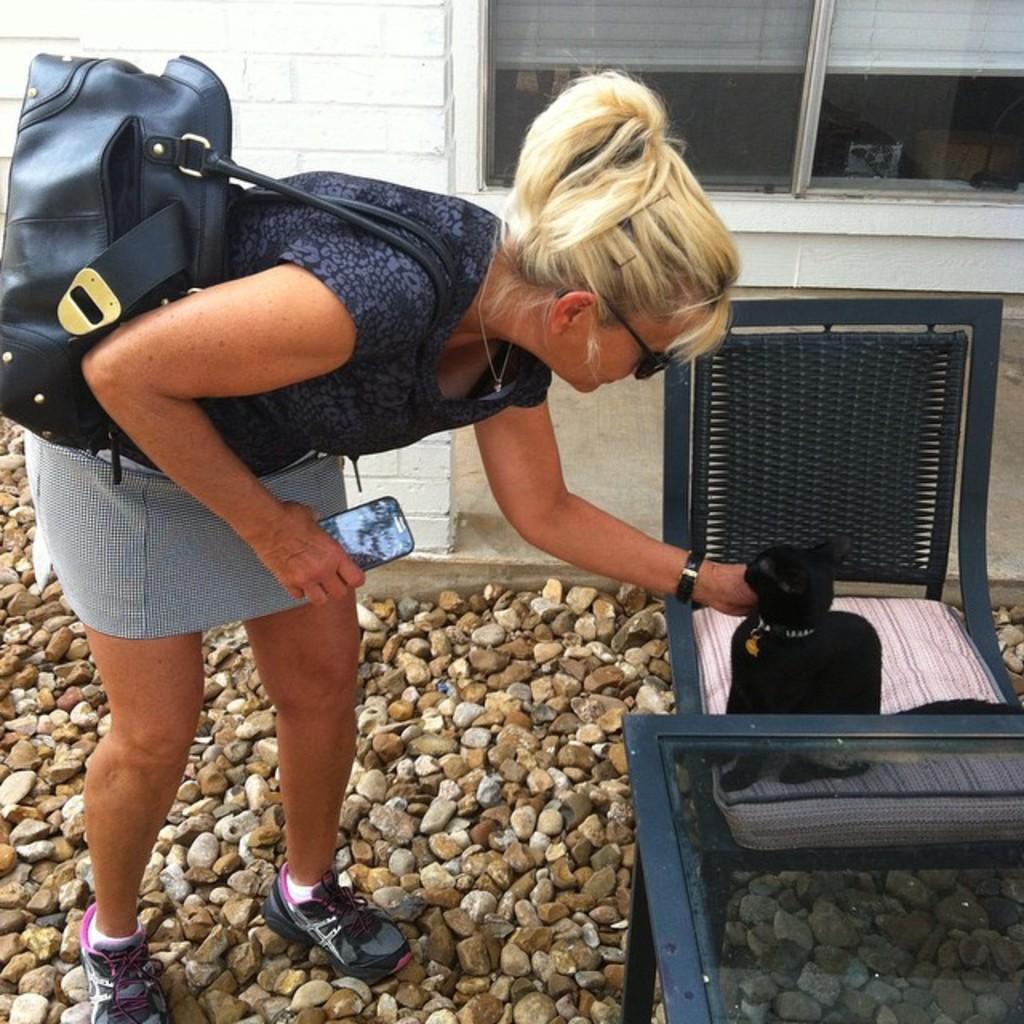Could you give a brief overview of what you see in this image? There is a person in black color t-shirt wearing a hand bag, holding a mobile with one hand, holding an object with other hand which is on the chair and bending on the stones in front of a table. In the background, there is a building which is having white wall and glass window. 